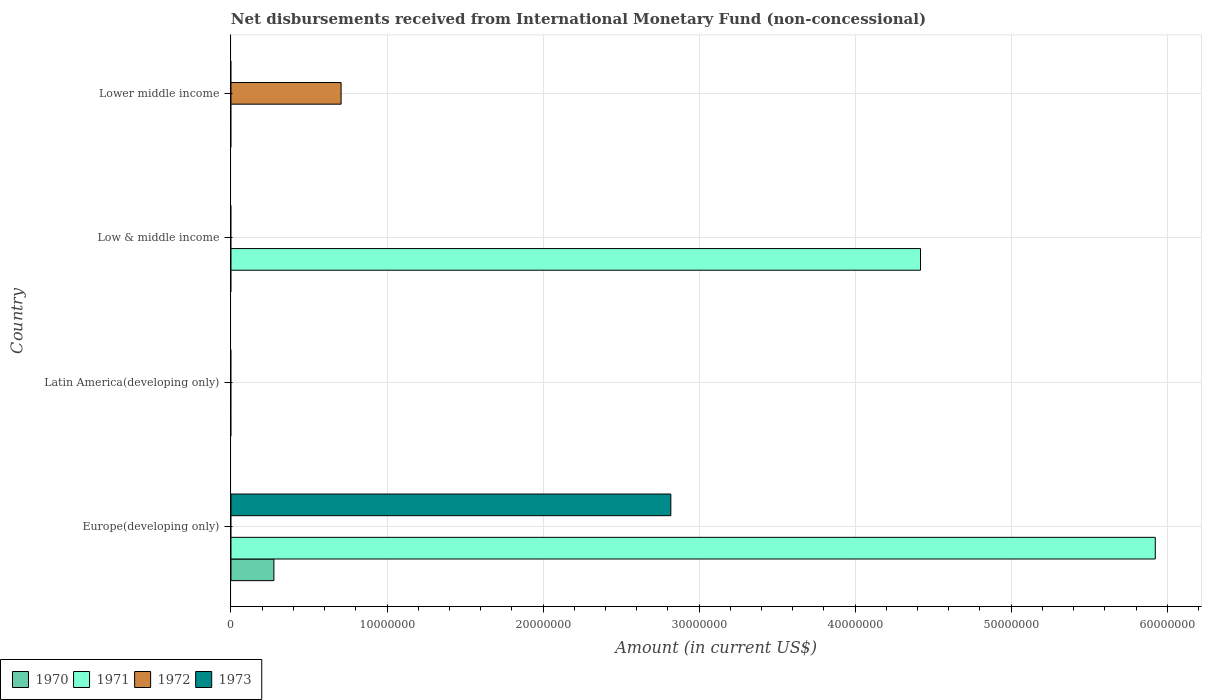Are the number of bars per tick equal to the number of legend labels?
Give a very brief answer. No. How many bars are there on the 3rd tick from the top?
Ensure brevity in your answer.  0. How many bars are there on the 1st tick from the bottom?
Your answer should be very brief. 3. What is the label of the 4th group of bars from the top?
Provide a short and direct response. Europe(developing only). What is the amount of disbursements received from International Monetary Fund in 1970 in Europe(developing only)?
Your response must be concise. 2.75e+06. Across all countries, what is the maximum amount of disbursements received from International Monetary Fund in 1971?
Offer a terse response. 5.92e+07. Across all countries, what is the minimum amount of disbursements received from International Monetary Fund in 1971?
Provide a succinct answer. 0. In which country was the amount of disbursements received from International Monetary Fund in 1972 maximum?
Offer a terse response. Lower middle income. What is the total amount of disbursements received from International Monetary Fund in 1972 in the graph?
Your response must be concise. 7.06e+06. What is the difference between the amount of disbursements received from International Monetary Fund in 1971 in Europe(developing only) and the amount of disbursements received from International Monetary Fund in 1972 in Lower middle income?
Offer a very short reply. 5.22e+07. What is the average amount of disbursements received from International Monetary Fund in 1970 per country?
Your response must be concise. 6.88e+05. In how many countries, is the amount of disbursements received from International Monetary Fund in 1971 greater than 2000000 US$?
Offer a very short reply. 2. What is the difference between the highest and the lowest amount of disbursements received from International Monetary Fund in 1973?
Offer a terse response. 2.82e+07. How many bars are there?
Your answer should be compact. 5. How many countries are there in the graph?
Provide a succinct answer. 4. Are the values on the major ticks of X-axis written in scientific E-notation?
Make the answer very short. No. Where does the legend appear in the graph?
Offer a very short reply. Bottom left. How many legend labels are there?
Keep it short and to the point. 4. How are the legend labels stacked?
Make the answer very short. Horizontal. What is the title of the graph?
Provide a short and direct response. Net disbursements received from International Monetary Fund (non-concessional). Does "2008" appear as one of the legend labels in the graph?
Your answer should be compact. No. What is the label or title of the Y-axis?
Your answer should be compact. Country. What is the Amount (in current US$) of 1970 in Europe(developing only)?
Keep it short and to the point. 2.75e+06. What is the Amount (in current US$) in 1971 in Europe(developing only)?
Ensure brevity in your answer.  5.92e+07. What is the Amount (in current US$) of 1973 in Europe(developing only)?
Give a very brief answer. 2.82e+07. What is the Amount (in current US$) in 1971 in Low & middle income?
Your answer should be very brief. 4.42e+07. What is the Amount (in current US$) of 1972 in Low & middle income?
Make the answer very short. 0. What is the Amount (in current US$) of 1973 in Low & middle income?
Provide a succinct answer. 0. What is the Amount (in current US$) of 1970 in Lower middle income?
Make the answer very short. 0. What is the Amount (in current US$) of 1972 in Lower middle income?
Offer a terse response. 7.06e+06. Across all countries, what is the maximum Amount (in current US$) of 1970?
Ensure brevity in your answer.  2.75e+06. Across all countries, what is the maximum Amount (in current US$) of 1971?
Your response must be concise. 5.92e+07. Across all countries, what is the maximum Amount (in current US$) in 1972?
Your answer should be very brief. 7.06e+06. Across all countries, what is the maximum Amount (in current US$) in 1973?
Your answer should be very brief. 2.82e+07. Across all countries, what is the minimum Amount (in current US$) in 1970?
Your response must be concise. 0. What is the total Amount (in current US$) in 1970 in the graph?
Offer a terse response. 2.75e+06. What is the total Amount (in current US$) in 1971 in the graph?
Offer a very short reply. 1.03e+08. What is the total Amount (in current US$) of 1972 in the graph?
Ensure brevity in your answer.  7.06e+06. What is the total Amount (in current US$) of 1973 in the graph?
Your response must be concise. 2.82e+07. What is the difference between the Amount (in current US$) of 1971 in Europe(developing only) and that in Low & middle income?
Your answer should be very brief. 1.50e+07. What is the difference between the Amount (in current US$) of 1970 in Europe(developing only) and the Amount (in current US$) of 1971 in Low & middle income?
Ensure brevity in your answer.  -4.14e+07. What is the difference between the Amount (in current US$) of 1970 in Europe(developing only) and the Amount (in current US$) of 1972 in Lower middle income?
Provide a succinct answer. -4.31e+06. What is the difference between the Amount (in current US$) in 1971 in Europe(developing only) and the Amount (in current US$) in 1972 in Lower middle income?
Offer a terse response. 5.22e+07. What is the difference between the Amount (in current US$) in 1971 in Low & middle income and the Amount (in current US$) in 1972 in Lower middle income?
Offer a very short reply. 3.71e+07. What is the average Amount (in current US$) in 1970 per country?
Keep it short and to the point. 6.88e+05. What is the average Amount (in current US$) in 1971 per country?
Make the answer very short. 2.59e+07. What is the average Amount (in current US$) in 1972 per country?
Offer a terse response. 1.76e+06. What is the average Amount (in current US$) of 1973 per country?
Provide a succinct answer. 7.05e+06. What is the difference between the Amount (in current US$) in 1970 and Amount (in current US$) in 1971 in Europe(developing only)?
Keep it short and to the point. -5.65e+07. What is the difference between the Amount (in current US$) of 1970 and Amount (in current US$) of 1973 in Europe(developing only)?
Keep it short and to the point. -2.54e+07. What is the difference between the Amount (in current US$) in 1971 and Amount (in current US$) in 1973 in Europe(developing only)?
Offer a terse response. 3.10e+07. What is the ratio of the Amount (in current US$) of 1971 in Europe(developing only) to that in Low & middle income?
Make the answer very short. 1.34. What is the difference between the highest and the lowest Amount (in current US$) of 1970?
Keep it short and to the point. 2.75e+06. What is the difference between the highest and the lowest Amount (in current US$) in 1971?
Your answer should be compact. 5.92e+07. What is the difference between the highest and the lowest Amount (in current US$) in 1972?
Offer a terse response. 7.06e+06. What is the difference between the highest and the lowest Amount (in current US$) in 1973?
Provide a succinct answer. 2.82e+07. 